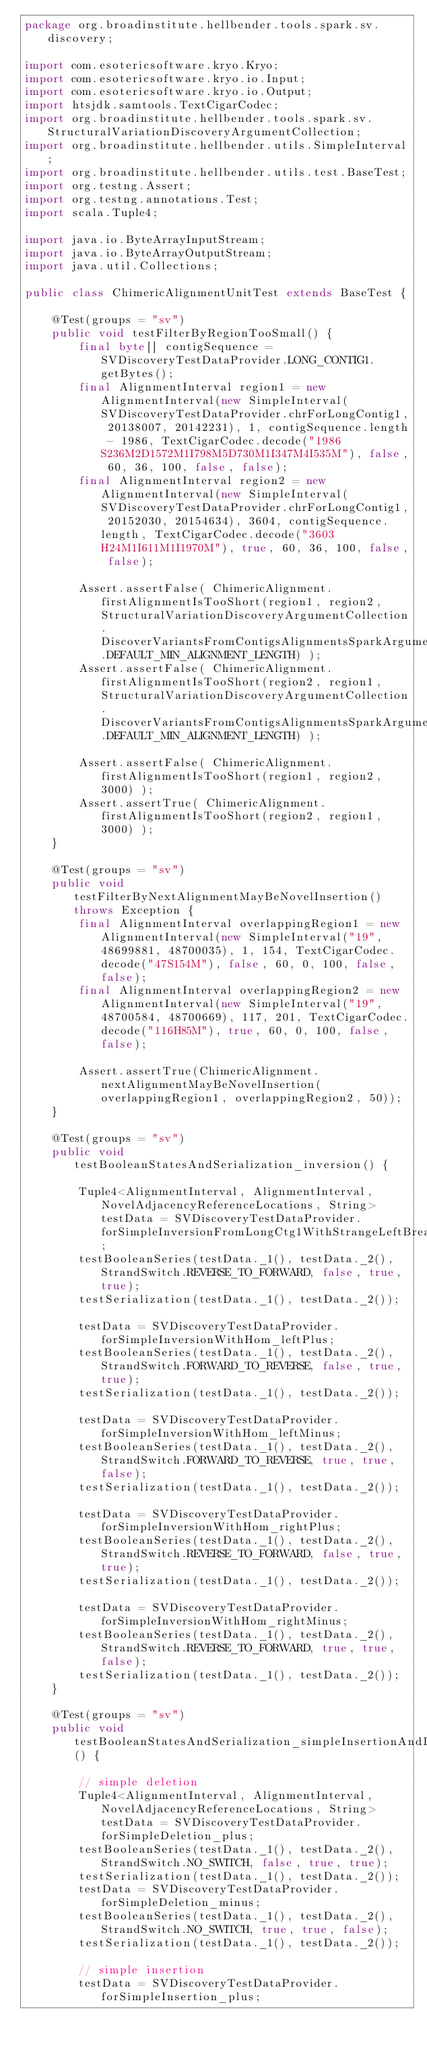<code> <loc_0><loc_0><loc_500><loc_500><_Java_>package org.broadinstitute.hellbender.tools.spark.sv.discovery;

import com.esotericsoftware.kryo.Kryo;
import com.esotericsoftware.kryo.io.Input;
import com.esotericsoftware.kryo.io.Output;
import htsjdk.samtools.TextCigarCodec;
import org.broadinstitute.hellbender.tools.spark.sv.StructuralVariationDiscoveryArgumentCollection;
import org.broadinstitute.hellbender.utils.SimpleInterval;
import org.broadinstitute.hellbender.utils.test.BaseTest;
import org.testng.Assert;
import org.testng.annotations.Test;
import scala.Tuple4;

import java.io.ByteArrayInputStream;
import java.io.ByteArrayOutputStream;
import java.util.Collections;

public class ChimericAlignmentUnitTest extends BaseTest {

    @Test(groups = "sv")
    public void testFilterByRegionTooSmall() {
        final byte[] contigSequence = SVDiscoveryTestDataProvider.LONG_CONTIG1.getBytes();
        final AlignmentInterval region1 = new AlignmentInterval(new SimpleInterval(SVDiscoveryTestDataProvider.chrForLongContig1, 20138007, 20142231), 1, contigSequence.length - 1986, TextCigarCodec.decode("1986S236M2D1572M1I798M5D730M1I347M4I535M"), false, 60, 36, 100, false, false);
        final AlignmentInterval region2 = new AlignmentInterval(new SimpleInterval(SVDiscoveryTestDataProvider.chrForLongContig1, 20152030, 20154634), 3604, contigSequence.length, TextCigarCodec.decode("3603H24M1I611M1I1970M"), true, 60, 36, 100, false, false);

        Assert.assertFalse( ChimericAlignment.firstAlignmentIsTooShort(region1, region2, StructuralVariationDiscoveryArgumentCollection.DiscoverVariantsFromContigsAlignmentsSparkArgumentCollection.DEFAULT_MIN_ALIGNMENT_LENGTH) );
        Assert.assertFalse( ChimericAlignment.firstAlignmentIsTooShort(region2, region1, StructuralVariationDiscoveryArgumentCollection.DiscoverVariantsFromContigsAlignmentsSparkArgumentCollection.DEFAULT_MIN_ALIGNMENT_LENGTH) );

        Assert.assertFalse( ChimericAlignment.firstAlignmentIsTooShort(region1, region2, 3000) );
        Assert.assertTrue( ChimericAlignment.firstAlignmentIsTooShort(region2, region1, 3000) );
    }

    @Test(groups = "sv")
    public void testFilterByNextAlignmentMayBeNovelInsertion() throws Exception {
        final AlignmentInterval overlappingRegion1 = new AlignmentInterval(new SimpleInterval("19", 48699881, 48700035), 1, 154, TextCigarCodec.decode("47S154M"), false, 60, 0, 100, false, false);
        final AlignmentInterval overlappingRegion2 = new AlignmentInterval(new SimpleInterval("19", 48700584, 48700669), 117, 201, TextCigarCodec.decode("116H85M"), true, 60, 0, 100, false, false);

        Assert.assertTrue(ChimericAlignment.nextAlignmentMayBeNovelInsertion(overlappingRegion1, overlappingRegion2, 50));
    }

    @Test(groups = "sv")
    public void testBooleanStatesAndSerialization_inversion() {

        Tuple4<AlignmentInterval, AlignmentInterval, NovelAdjacencyReferenceLocations, String> testData = SVDiscoveryTestDataProvider.forSimpleInversionFromLongCtg1WithStrangeLeftBreakpoint;
        testBooleanSeries(testData._1(), testData._2(), StrandSwitch.REVERSE_TO_FORWARD, false, true, true);
        testSerialization(testData._1(), testData._2());

        testData = SVDiscoveryTestDataProvider.forSimpleInversionWithHom_leftPlus;
        testBooleanSeries(testData._1(), testData._2(), StrandSwitch.FORWARD_TO_REVERSE, false, true, true);
        testSerialization(testData._1(), testData._2());

        testData = SVDiscoveryTestDataProvider.forSimpleInversionWithHom_leftMinus;
        testBooleanSeries(testData._1(), testData._2(), StrandSwitch.FORWARD_TO_REVERSE, true, true, false);
        testSerialization(testData._1(), testData._2());

        testData = SVDiscoveryTestDataProvider.forSimpleInversionWithHom_rightPlus;
        testBooleanSeries(testData._1(), testData._2(), StrandSwitch.REVERSE_TO_FORWARD, false, true, true);
        testSerialization(testData._1(), testData._2());

        testData = SVDiscoveryTestDataProvider.forSimpleInversionWithHom_rightMinus;
        testBooleanSeries(testData._1(), testData._2(), StrandSwitch.REVERSE_TO_FORWARD, true, true, false);
        testSerialization(testData._1(), testData._2());
    }

    @Test(groups = "sv")
    public void testBooleanStatesAndSerialization_simpleInsertionAndDeletion() {

        // simple deletion
        Tuple4<AlignmentInterval, AlignmentInterval, NovelAdjacencyReferenceLocations, String> testData = SVDiscoveryTestDataProvider.forSimpleDeletion_plus;
        testBooleanSeries(testData._1(), testData._2(), StrandSwitch.NO_SWITCH, false, true, true);
        testSerialization(testData._1(), testData._2());
        testData = SVDiscoveryTestDataProvider.forSimpleDeletion_minus;
        testBooleanSeries(testData._1(), testData._2(), StrandSwitch.NO_SWITCH, true, true, false);
        testSerialization(testData._1(), testData._2());

        // simple insertion
        testData = SVDiscoveryTestDataProvider.forSimpleInsertion_plus;</code> 